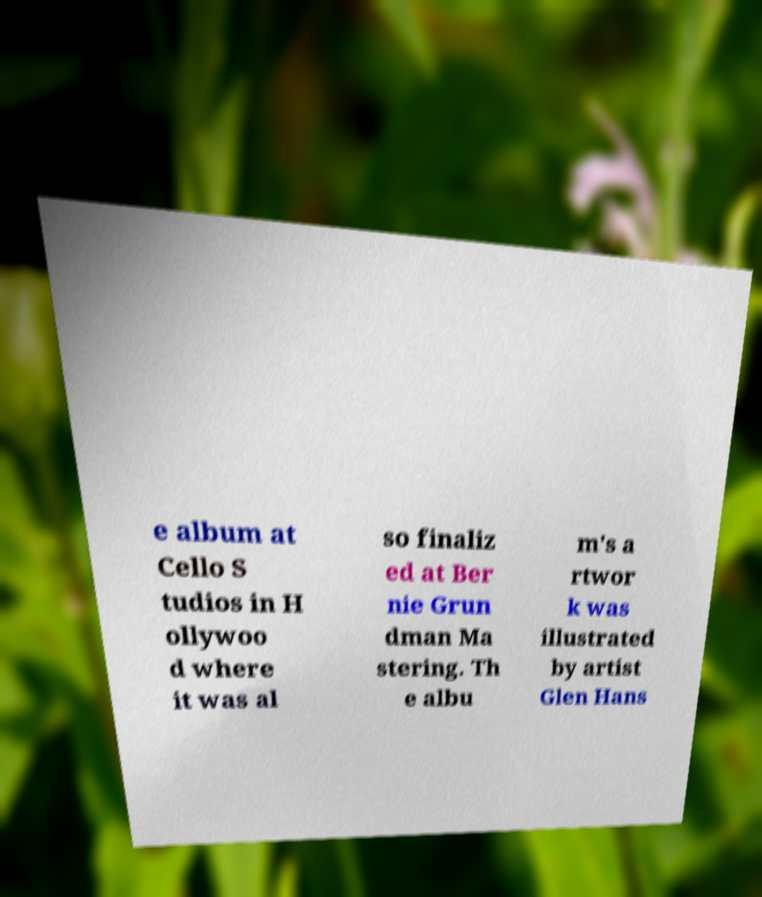Can you read and provide the text displayed in the image?This photo seems to have some interesting text. Can you extract and type it out for me? e album at Cello S tudios in H ollywoo d where it was al so finaliz ed at Ber nie Grun dman Ma stering. Th e albu m's a rtwor k was illustrated by artist Glen Hans 